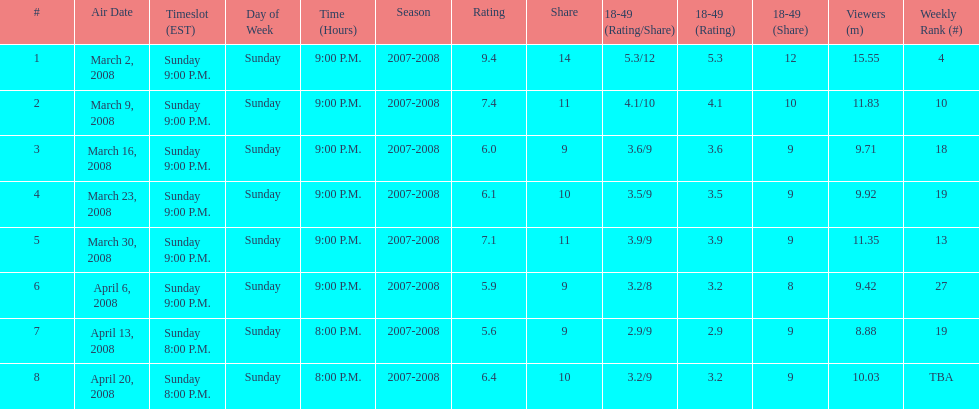Which show had the highest rating? 1. 